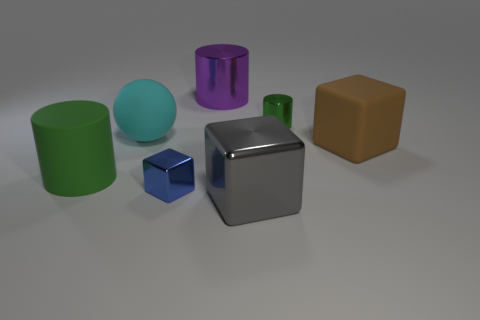Do the small object that is behind the green rubber thing and the purple metallic object have the same shape?
Your answer should be very brief. Yes. The big purple metal thing is what shape?
Your answer should be compact. Cylinder. What material is the large cylinder that is in front of the rubber thing that is behind the large thing on the right side of the small green metal cylinder?
Provide a short and direct response. Rubber. There is another cylinder that is the same color as the small cylinder; what material is it?
Keep it short and to the point. Rubber. What number of things are either small purple cylinders or tiny blue metallic blocks?
Offer a very short reply. 1. Do the tiny thing that is on the left side of the gray metal block and the sphere have the same material?
Provide a succinct answer. No. What number of objects are cubes behind the blue block or large things?
Offer a terse response. 5. What color is the small cylinder that is the same material as the gray block?
Provide a short and direct response. Green. Is there a rubber cube that has the same size as the purple metallic cylinder?
Your response must be concise. Yes. Is the color of the cylinder that is to the right of the large purple metal cylinder the same as the matte cylinder?
Ensure brevity in your answer.  Yes. 